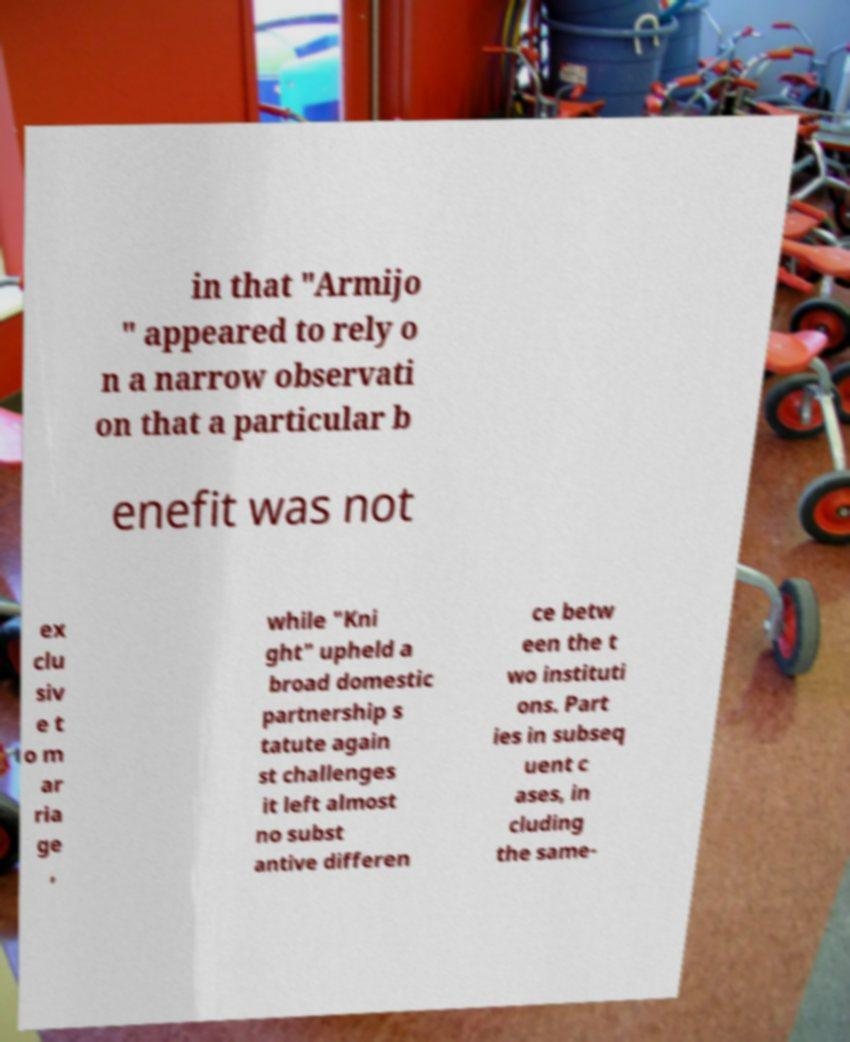There's text embedded in this image that I need extracted. Can you transcribe it verbatim? in that "Armijo " appeared to rely o n a narrow observati on that a particular b enefit was not ex clu siv e t o m ar ria ge , while "Kni ght" upheld a broad domestic partnership s tatute again st challenges it left almost no subst antive differen ce betw een the t wo instituti ons. Part ies in subseq uent c ases, in cluding the same- 